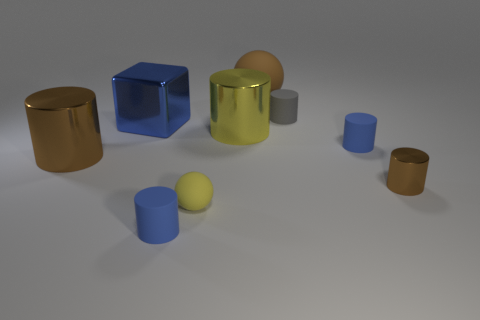Subtract 3 cylinders. How many cylinders are left? 3 Subtract all blue rubber cylinders. How many cylinders are left? 4 Subtract all gray cylinders. How many cylinders are left? 5 Subtract all gray cylinders. Subtract all blue spheres. How many cylinders are left? 5 Add 1 large brown cylinders. How many objects exist? 10 Subtract all cylinders. How many objects are left? 3 Add 6 large cylinders. How many large cylinders are left? 8 Add 9 large brown spheres. How many large brown spheres exist? 10 Subtract 0 purple spheres. How many objects are left? 9 Subtract all green matte objects. Subtract all big blue blocks. How many objects are left? 8 